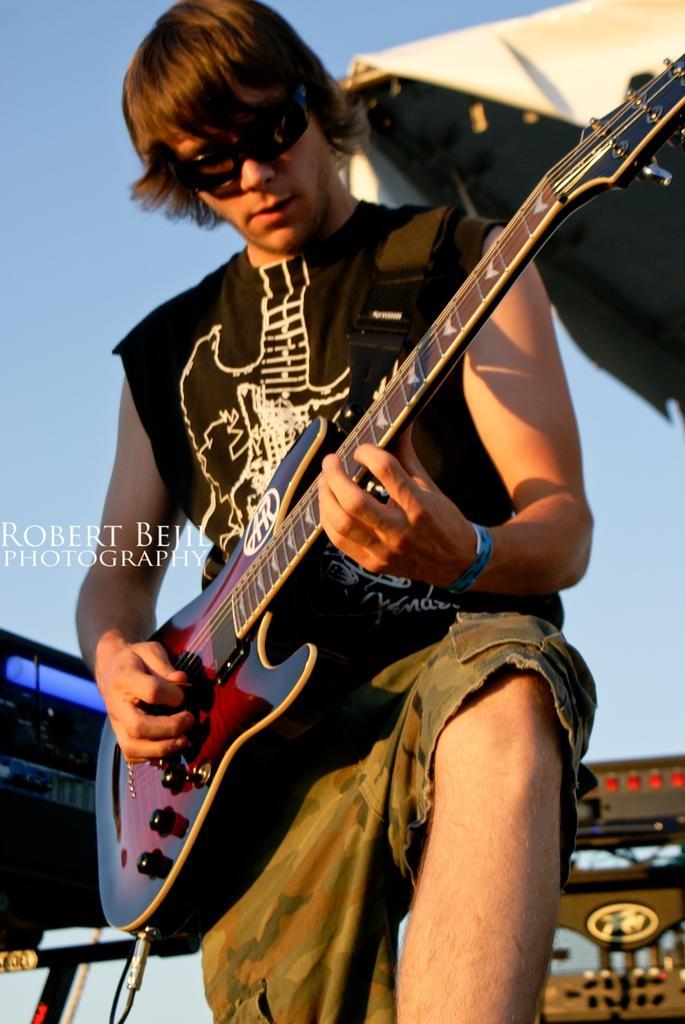How would you summarize this image in a sentence or two? This image is taken in outdoors. In this image there is a man standing holding a guitar, playing a music. At the background there is a sky and the man is wearing a shades. 